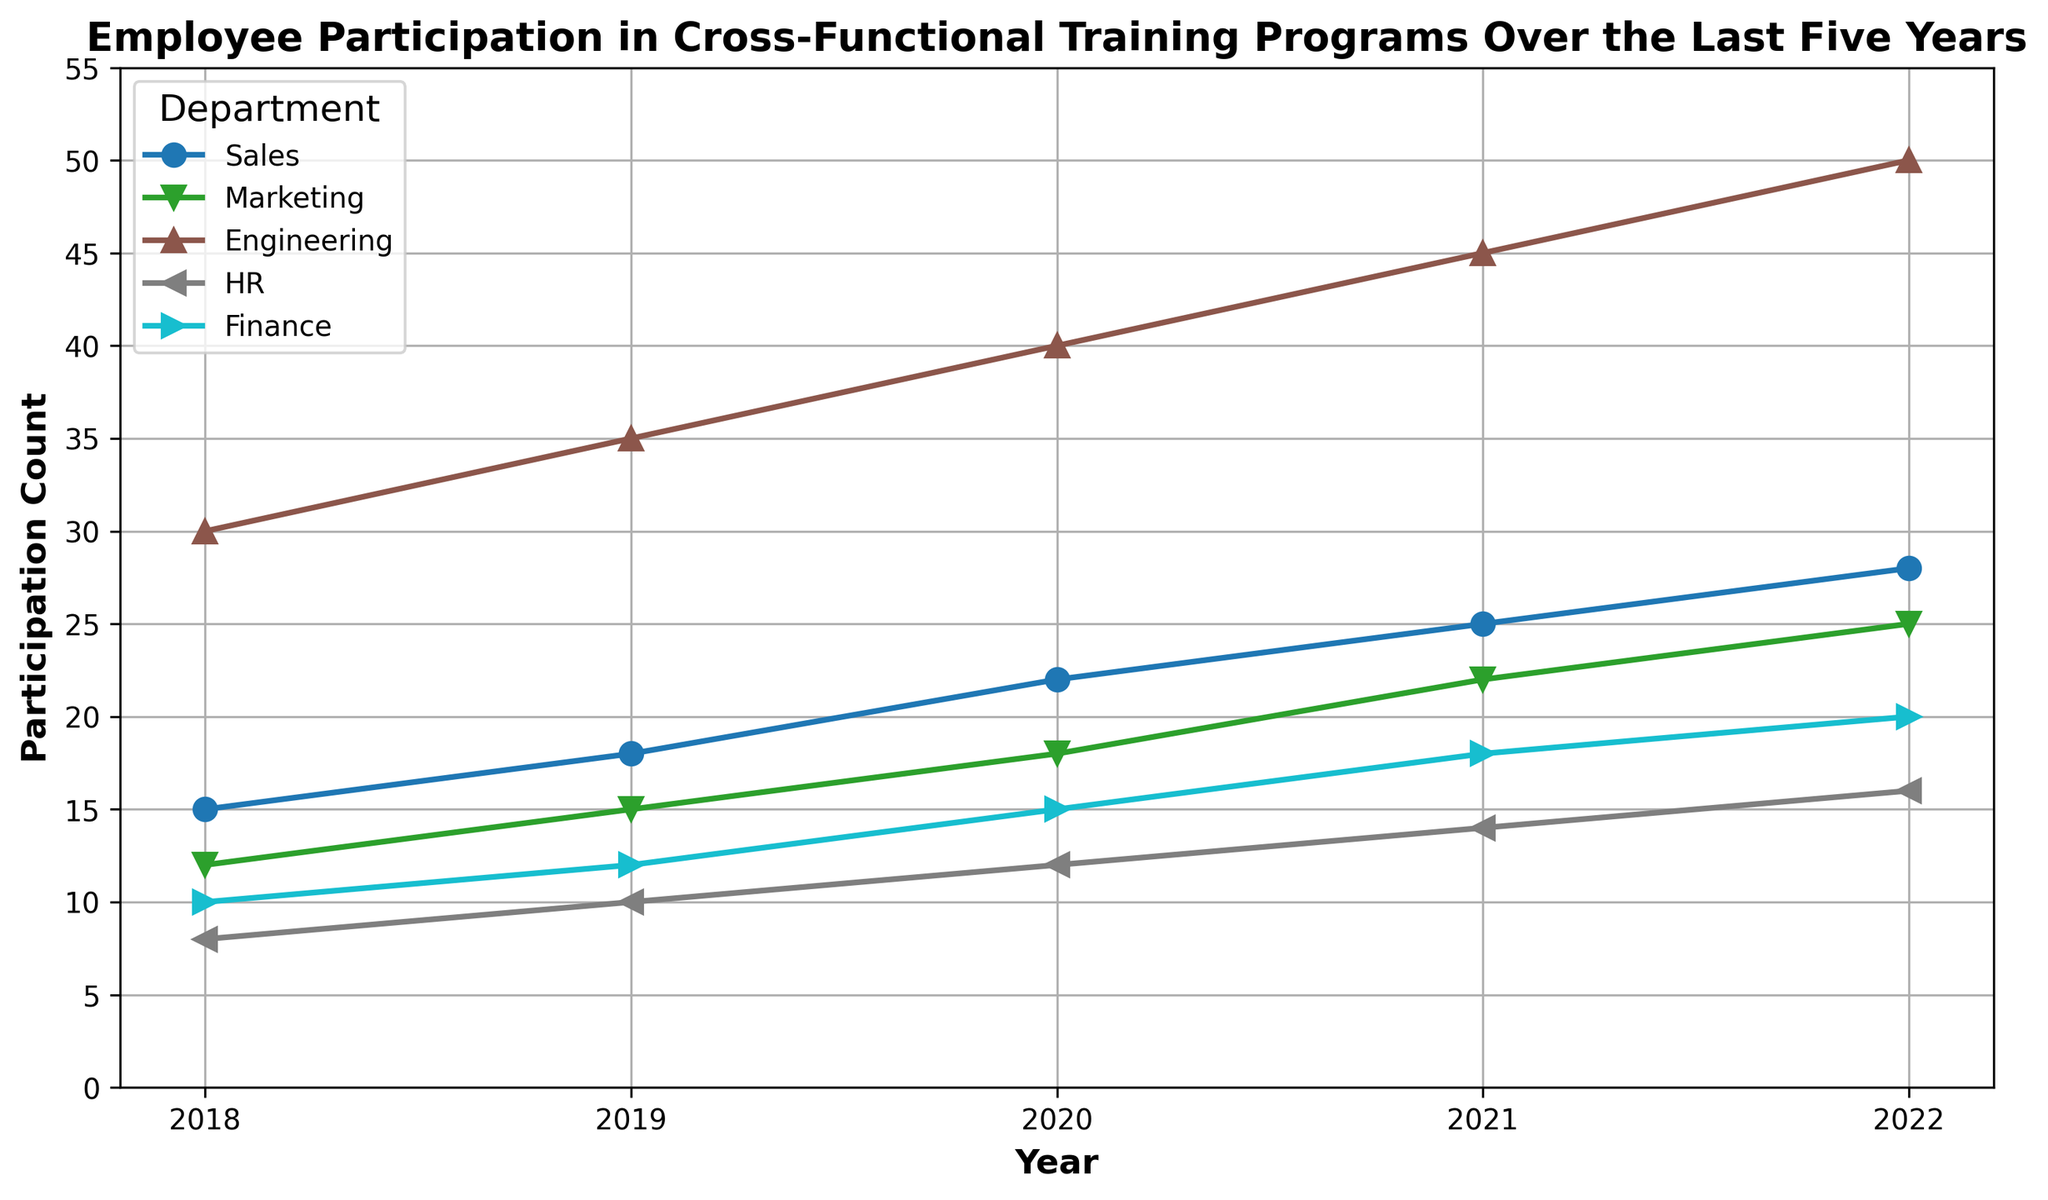How has the participation in cross-functional training programs changed for the Sales department from 2018 to 2022? Check the data point for Sales in 2018 and compare it with the data point in 2022. Participation in 2018 was 15, and it increased to 28 in 2022.
Answer: Increased from 15 to 28 Which department had the highest participation in 2022? Find the department with the highest data point in 2022. Engineering had the highest participation with 50 participants.
Answer: Engineering How many total participants were there in cross-functional training programs in 2020 across all departments? Sum the participation counts for all departments in 2020. The counts are 22 (Sales) + 18 (Marketing) + 40 (Engineering) + 12 (HR) + 15 (Finance) = 107.
Answer: 107 Which year saw the highest increase in participation for the Marketing department compared to the previous year? Calculate the difference in participation counts for Marketing between consecutive years and find the largest increase. Differences: 2019-2018 = 15-12=3; 2020-2019 = 18-15=3; 2021-2020 = 22-18=4; 2022-2021 = 25-22=3. The highest increase occurred between 2020 and 2021.
Answer: 2021 What is the average yearly participation in cross-functional training programs for the Engineering department from 2018 to 2022? Sum the participation counts for the Engineering department from 2018 to 2022 and divide by the number of years. (30 + 35 + 40 + 45 + 50) / 5 = 200 / 5 = 40.
Answer: 40 Compare the trend of participation between HR and Finance departments from 2018 to 2022. Look at the lines representing the HR and Finance departments from 2018 to 2022. Both lines show an increasing trend, but Finance consistently has higher participation than HR.
Answer: Both increasing, Finance higher Which department had the least participation in 2019, and how much was it? Identify the department with the lowest data point in 2019. HR had the lowest participation with 10 participants.
Answer: HR, 10 What is the difference in participation counts between the departments with the highest and lowest participation in 2021? Find the highest and lowest participation counts in 2021 and calculate the difference. Engineering had the highest (45) and HR had the lowest (14). The difference is 45 - 14 = 31.
Answer: 31 How does the overall trend in participation for the Finance department compare to the Sales department from 2018 to 2022? Compare the slope and direction of the lines for Finance and Sales from 2018 to 2022. Both departments show an upward trend, but Sales has a steeper increase in participation than Finance.
Answer: Both increasing, Sales steeper What is the median participation count in 2020 across all departments? Arrange the participation counts for 2020 in ascending order and find the middle value. The counts are 12, 15, 18, 22, 40. The median is 18.
Answer: 18 